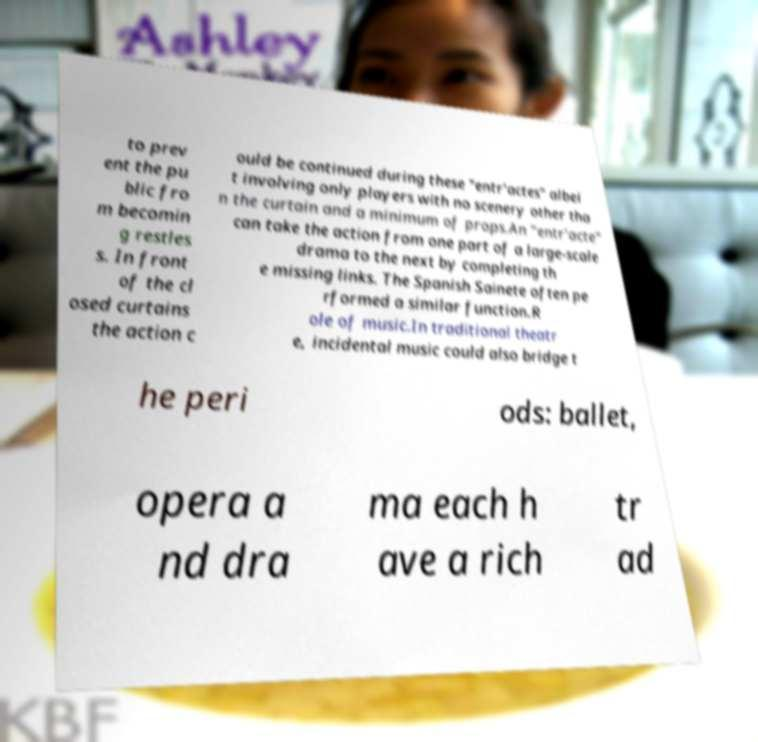There's text embedded in this image that I need extracted. Can you transcribe it verbatim? to prev ent the pu blic fro m becomin g restles s. In front of the cl osed curtains the action c ould be continued during these "entr'actes" albei t involving only players with no scenery other tha n the curtain and a minimum of props.An "entr'acte" can take the action from one part of a large-scale drama to the next by completing th e missing links. The Spanish Sainete often pe rformed a similar function.R ole of music.In traditional theatr e, incidental music could also bridge t he peri ods: ballet, opera a nd dra ma each h ave a rich tr ad 